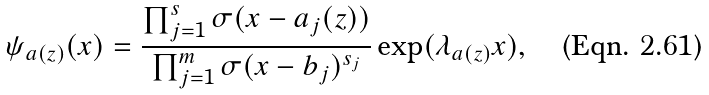<formula> <loc_0><loc_0><loc_500><loc_500>\psi _ { a ( z ) } ( x ) = \frac { \prod _ { j = 1 } ^ { s } \sigma ( x - a _ { j } ( z ) ) } { \prod _ { j = 1 } ^ { m } \sigma ( x - b _ { j } ) ^ { s _ { j } } } \exp ( \lambda _ { a ( z ) } x ) ,</formula> 